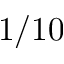<formula> <loc_0><loc_0><loc_500><loc_500>1 / 1 0</formula> 